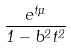Convert formula to latex. <formula><loc_0><loc_0><loc_500><loc_500>\frac { e ^ { t \mu } } { 1 - b ^ { 2 } t ^ { 2 } }</formula> 